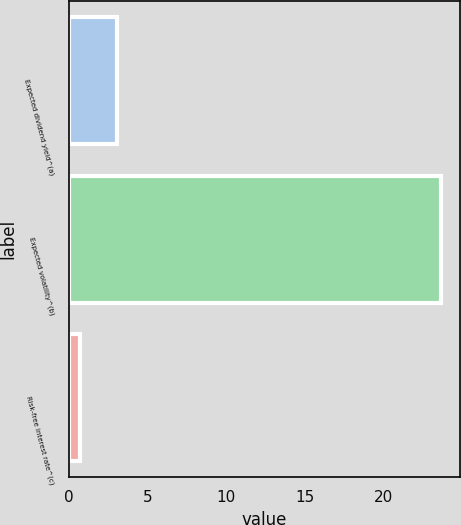Convert chart to OTSL. <chart><loc_0><loc_0><loc_500><loc_500><bar_chart><fcel>Expected dividend yield^(a)<fcel>Expected volatility^(b)<fcel>Risk-free interest rate^(c)<nl><fcel>3.05<fcel>23.66<fcel>0.76<nl></chart> 